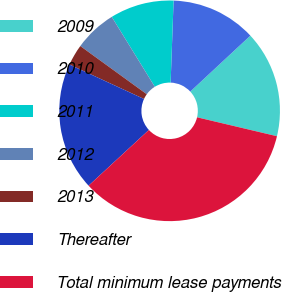<chart> <loc_0><loc_0><loc_500><loc_500><pie_chart><fcel>2009<fcel>2010<fcel>2011<fcel>2012<fcel>2013<fcel>Thereafter<fcel>Total minimum lease payments<nl><fcel>15.63%<fcel>12.5%<fcel>9.36%<fcel>6.23%<fcel>3.1%<fcel>18.76%<fcel>34.43%<nl></chart> 